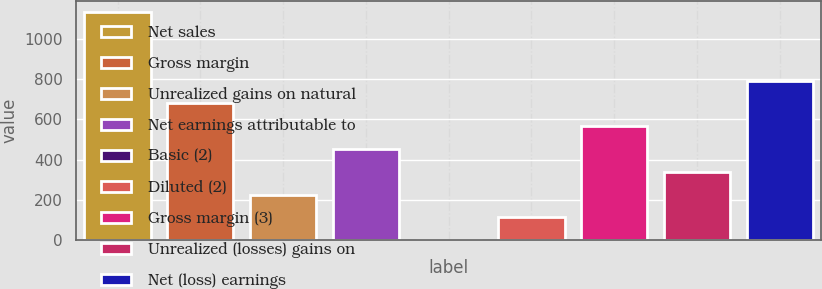Convert chart. <chart><loc_0><loc_0><loc_500><loc_500><bar_chart><fcel>Net sales<fcel>Gross margin<fcel>Unrealized gains on natural<fcel>Net earnings attributable to<fcel>Basic (2)<fcel>Diluted (2)<fcel>Gross margin (3)<fcel>Unrealized (losses) gains on<fcel>Net (loss) earnings<nl><fcel>1132<fcel>679.29<fcel>226.57<fcel>452.93<fcel>0.21<fcel>113.39<fcel>566.11<fcel>339.75<fcel>792.47<nl></chart> 